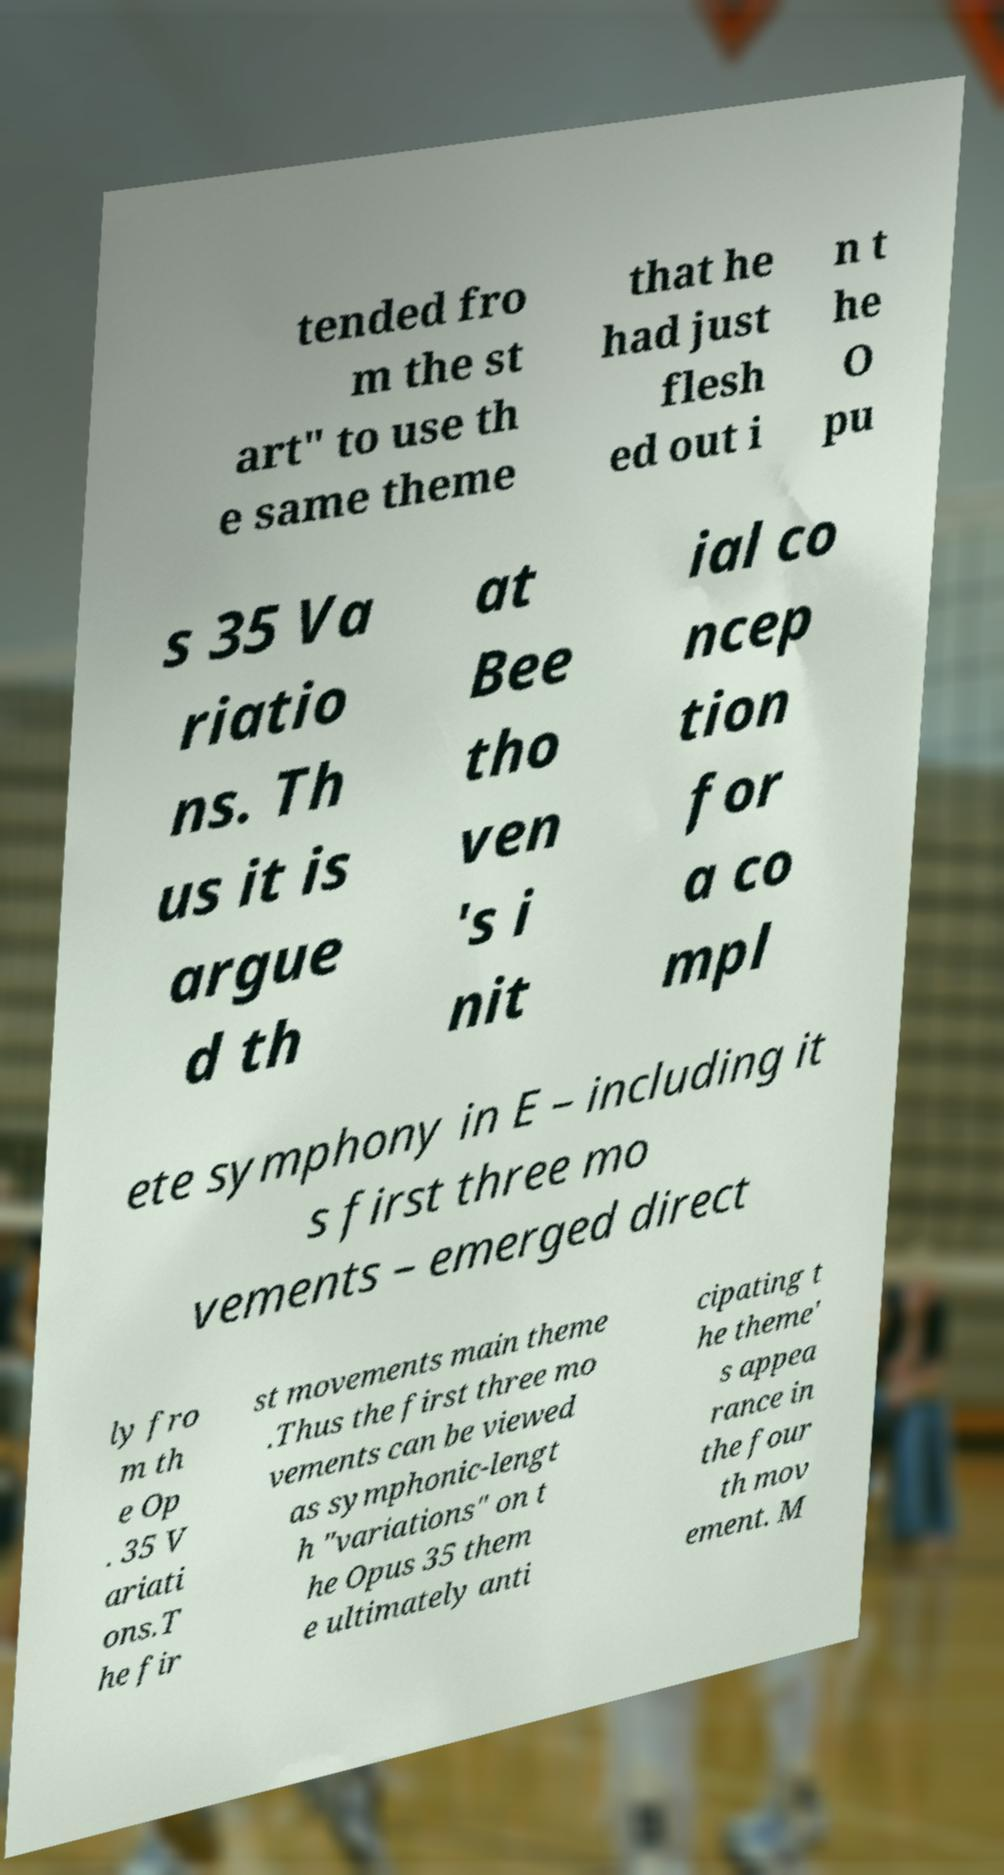Please read and relay the text visible in this image. What does it say? tended fro m the st art" to use th e same theme that he had just flesh ed out i n t he O pu s 35 Va riatio ns. Th us it is argue d th at Bee tho ven 's i nit ial co ncep tion for a co mpl ete symphony in E – including it s first three mo vements – emerged direct ly fro m th e Op . 35 V ariati ons.T he fir st movements main theme .Thus the first three mo vements can be viewed as symphonic-lengt h "variations" on t he Opus 35 them e ultimately anti cipating t he theme' s appea rance in the four th mov ement. M 